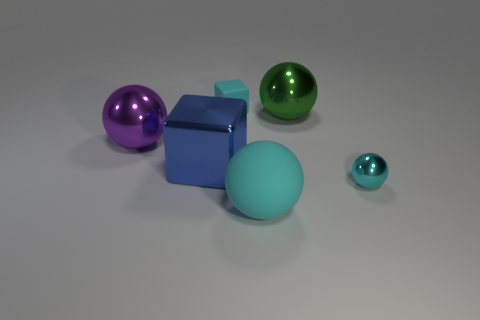Subtract all small balls. How many balls are left? 3 Subtract all large cyan rubber things. Subtract all metal objects. How many objects are left? 1 Add 5 large purple things. How many large purple things are left? 6 Add 2 big metallic blocks. How many big metallic blocks exist? 3 Add 1 big spheres. How many objects exist? 7 Subtract all purple balls. How many balls are left? 3 Subtract 1 cyan blocks. How many objects are left? 5 Subtract all spheres. How many objects are left? 2 Subtract 2 balls. How many balls are left? 2 Subtract all brown spheres. Subtract all green cylinders. How many spheres are left? 4 